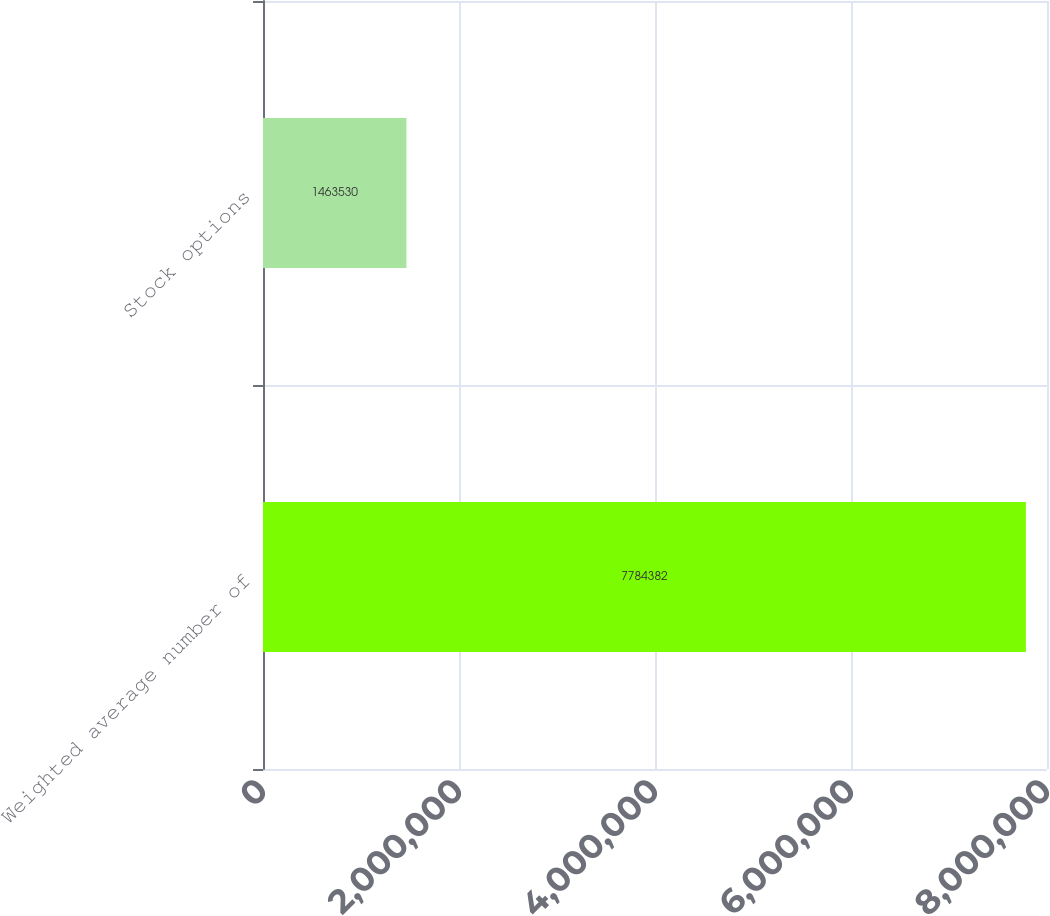<chart> <loc_0><loc_0><loc_500><loc_500><bar_chart><fcel>Weighted average number of<fcel>Stock options<nl><fcel>7.78438e+06<fcel>1.46353e+06<nl></chart> 